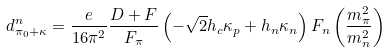Convert formula to latex. <formula><loc_0><loc_0><loc_500><loc_500>d ^ { n } _ { \pi _ { 0 } + \kappa } = \frac { e } { 1 6 \pi ^ { 2 } } \frac { D + F } { F _ { \pi } } \left ( - \sqrt { 2 } h _ { c } \kappa _ { p } + h _ { n } \kappa _ { n } \right ) F _ { n } \left ( \frac { m _ { \pi } ^ { 2 } } { m _ { n } ^ { 2 } } \right )</formula> 